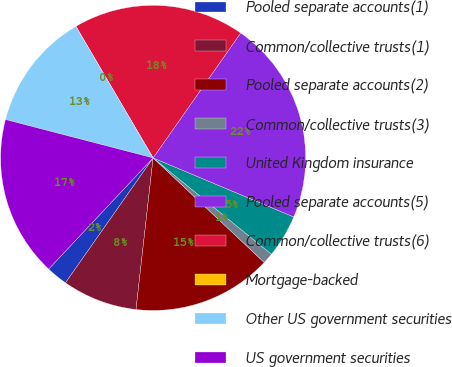<chart> <loc_0><loc_0><loc_500><loc_500><pie_chart><fcel>Pooled separate accounts(1)<fcel>Common/collective trusts(1)<fcel>Pooled separate accounts(2)<fcel>Common/collective trusts(3)<fcel>United Kingdom insurance<fcel>Pooled separate accounts(5)<fcel>Common/collective trusts(6)<fcel>Mortgage-backed<fcel>Other US government securities<fcel>US government securities<nl><fcel>2.27%<fcel>7.95%<fcel>14.77%<fcel>1.14%<fcel>4.55%<fcel>21.59%<fcel>18.18%<fcel>0.0%<fcel>12.5%<fcel>17.04%<nl></chart> 